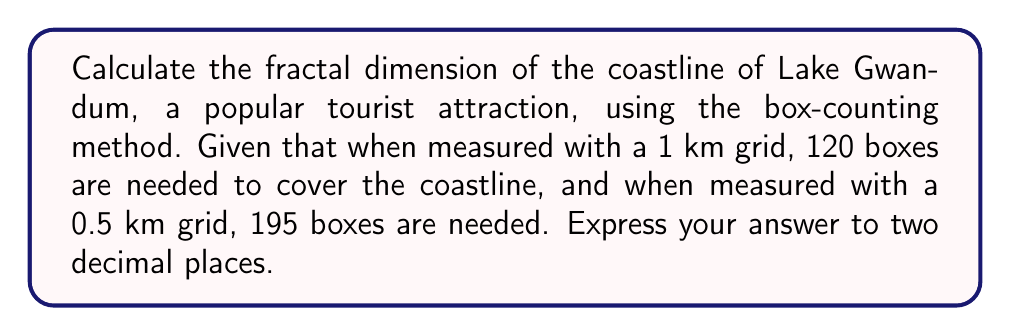What is the answer to this math problem? To calculate the fractal dimension using the box-counting method, we use the formula:

$$D = \frac{\log(N_2) - \log(N_1)}{\log(1/r_2) - \log(1/r_1)}$$

Where:
$D$ is the fractal dimension
$N_1$ and $N_2$ are the number of boxes needed for each measurement
$r_1$ and $r_2$ are the sizes of the boxes used

Step 1: Identify the values
$N_1 = 120$ (1 km grid)
$N_2 = 195$ (0.5 km grid)
$r_1 = 1$ km
$r_2 = 0.5$ km

Step 2: Substitute these values into the formula
$$D = \frac{\log(195) - \log(120)}{\log(1/0.5) - \log(1/1)}$$

Step 3: Simplify
$$D = \frac{\log(195) - \log(120)}{\log(2) - \log(1)}$$

Step 4: Calculate
$$D = \frac{5.2730 - 4.7875}{0.6931 - 0} \approx 1.7008$$

Step 5: Round to two decimal places
$D \approx 1.70$
Answer: 1.70 